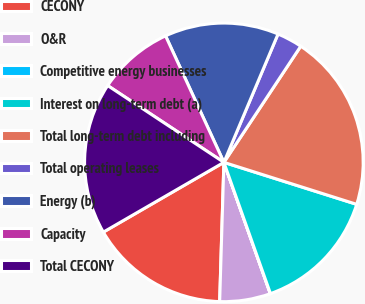Convert chart. <chart><loc_0><loc_0><loc_500><loc_500><pie_chart><fcel>CECONY<fcel>O&R<fcel>Competitive energy businesses<fcel>Interest on long-term debt (a)<fcel>Total long-term debt including<fcel>Total operating leases<fcel>Energy (b)<fcel>Capacity<fcel>Total CECONY<nl><fcel>16.17%<fcel>5.89%<fcel>0.02%<fcel>14.7%<fcel>20.57%<fcel>2.95%<fcel>13.23%<fcel>8.83%<fcel>17.64%<nl></chart> 